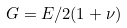Convert formula to latex. <formula><loc_0><loc_0><loc_500><loc_500>G = E / 2 ( 1 + \nu )</formula> 